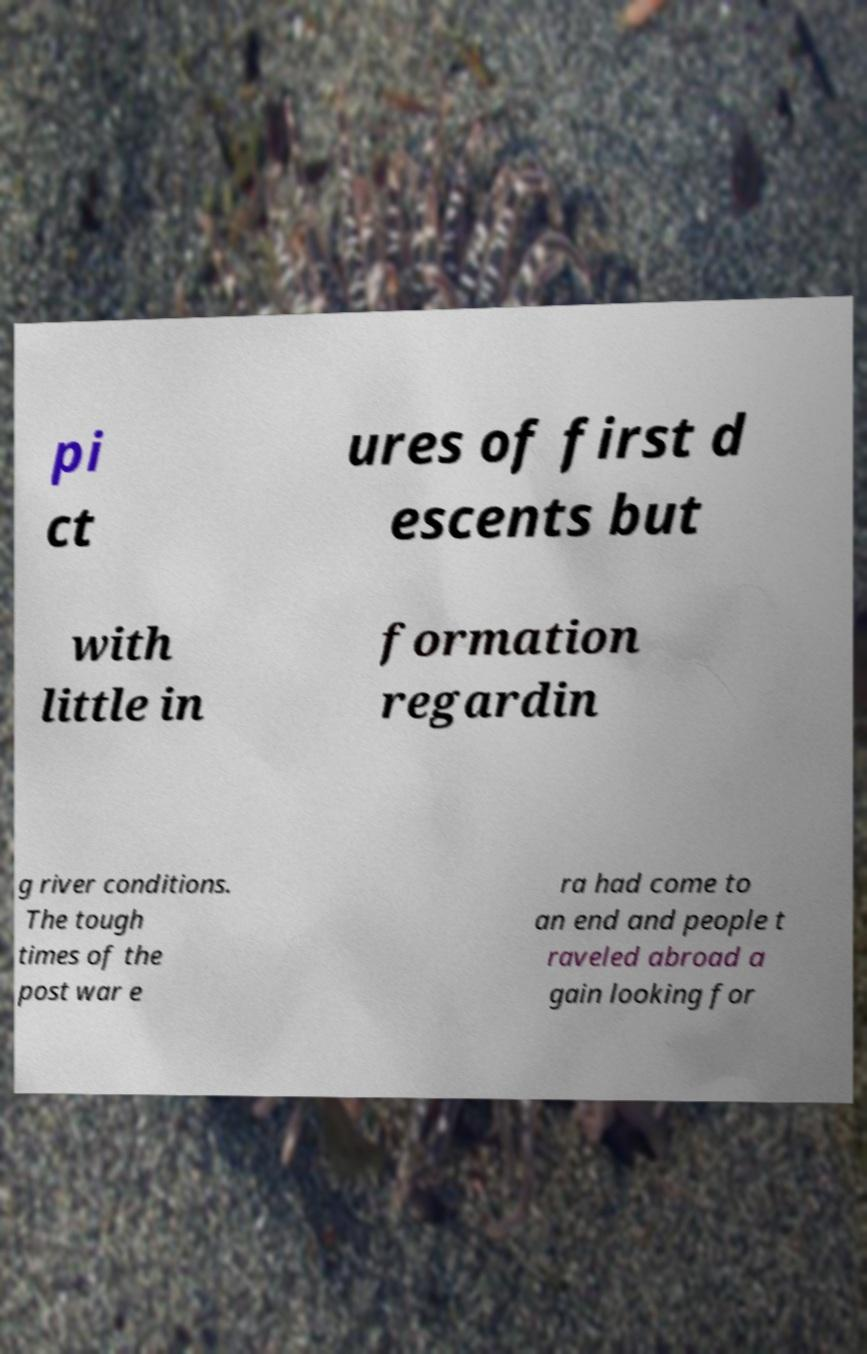Can you accurately transcribe the text from the provided image for me? pi ct ures of first d escents but with little in formation regardin g river conditions. The tough times of the post war e ra had come to an end and people t raveled abroad a gain looking for 